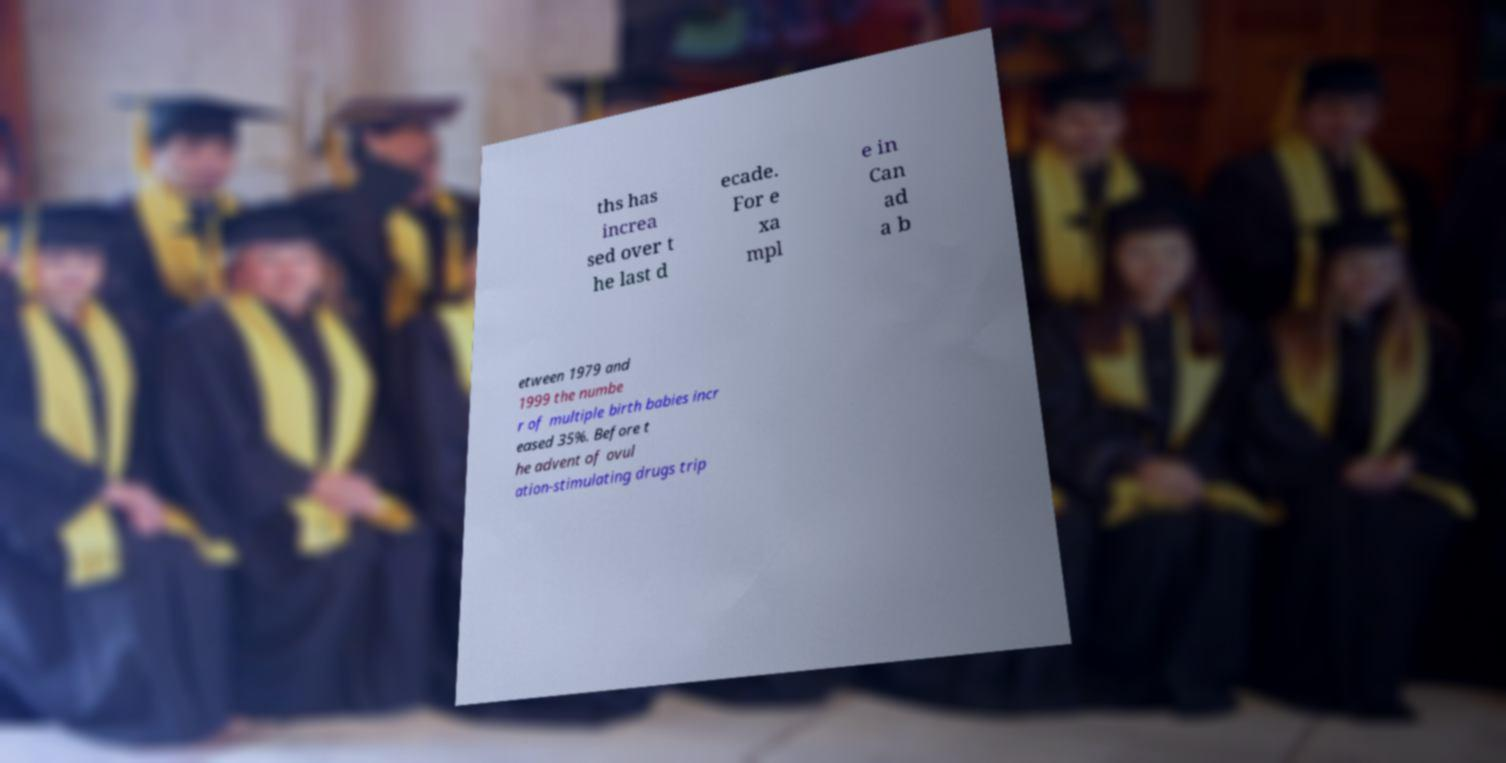Please read and relay the text visible in this image. What does it say? ths has increa sed over t he last d ecade. For e xa mpl e in Can ad a b etween 1979 and 1999 the numbe r of multiple birth babies incr eased 35%. Before t he advent of ovul ation-stimulating drugs trip 